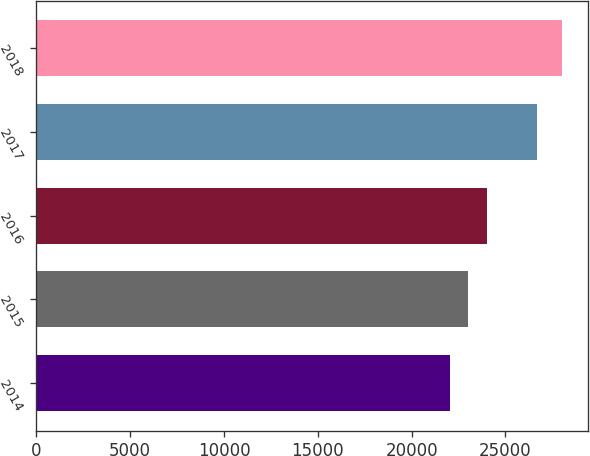Convert chart. <chart><loc_0><loc_0><loc_500><loc_500><bar_chart><fcel>2014<fcel>2015<fcel>2016<fcel>2017<fcel>2018<nl><fcel>22039<fcel>23000<fcel>24000<fcel>26700<fcel>28000<nl></chart> 